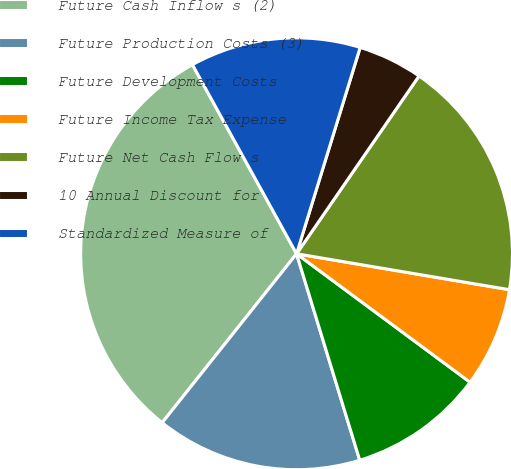Convert chart. <chart><loc_0><loc_0><loc_500><loc_500><pie_chart><fcel>Future Cash Inflow s (2)<fcel>Future Production Costs (3)<fcel>Future Development Costs<fcel>Future Income Tax Expense<fcel>Future Net Cash Flow s<fcel>10 Annual Discount for<fcel>Standardized Measure of<nl><fcel>31.29%<fcel>15.42%<fcel>10.13%<fcel>7.48%<fcel>18.06%<fcel>4.84%<fcel>12.77%<nl></chart> 